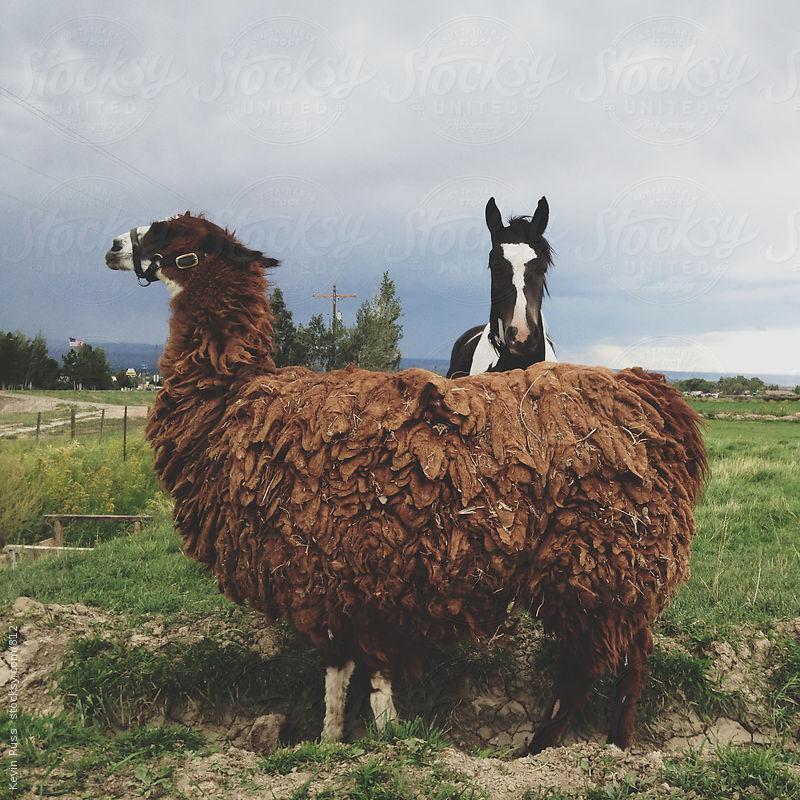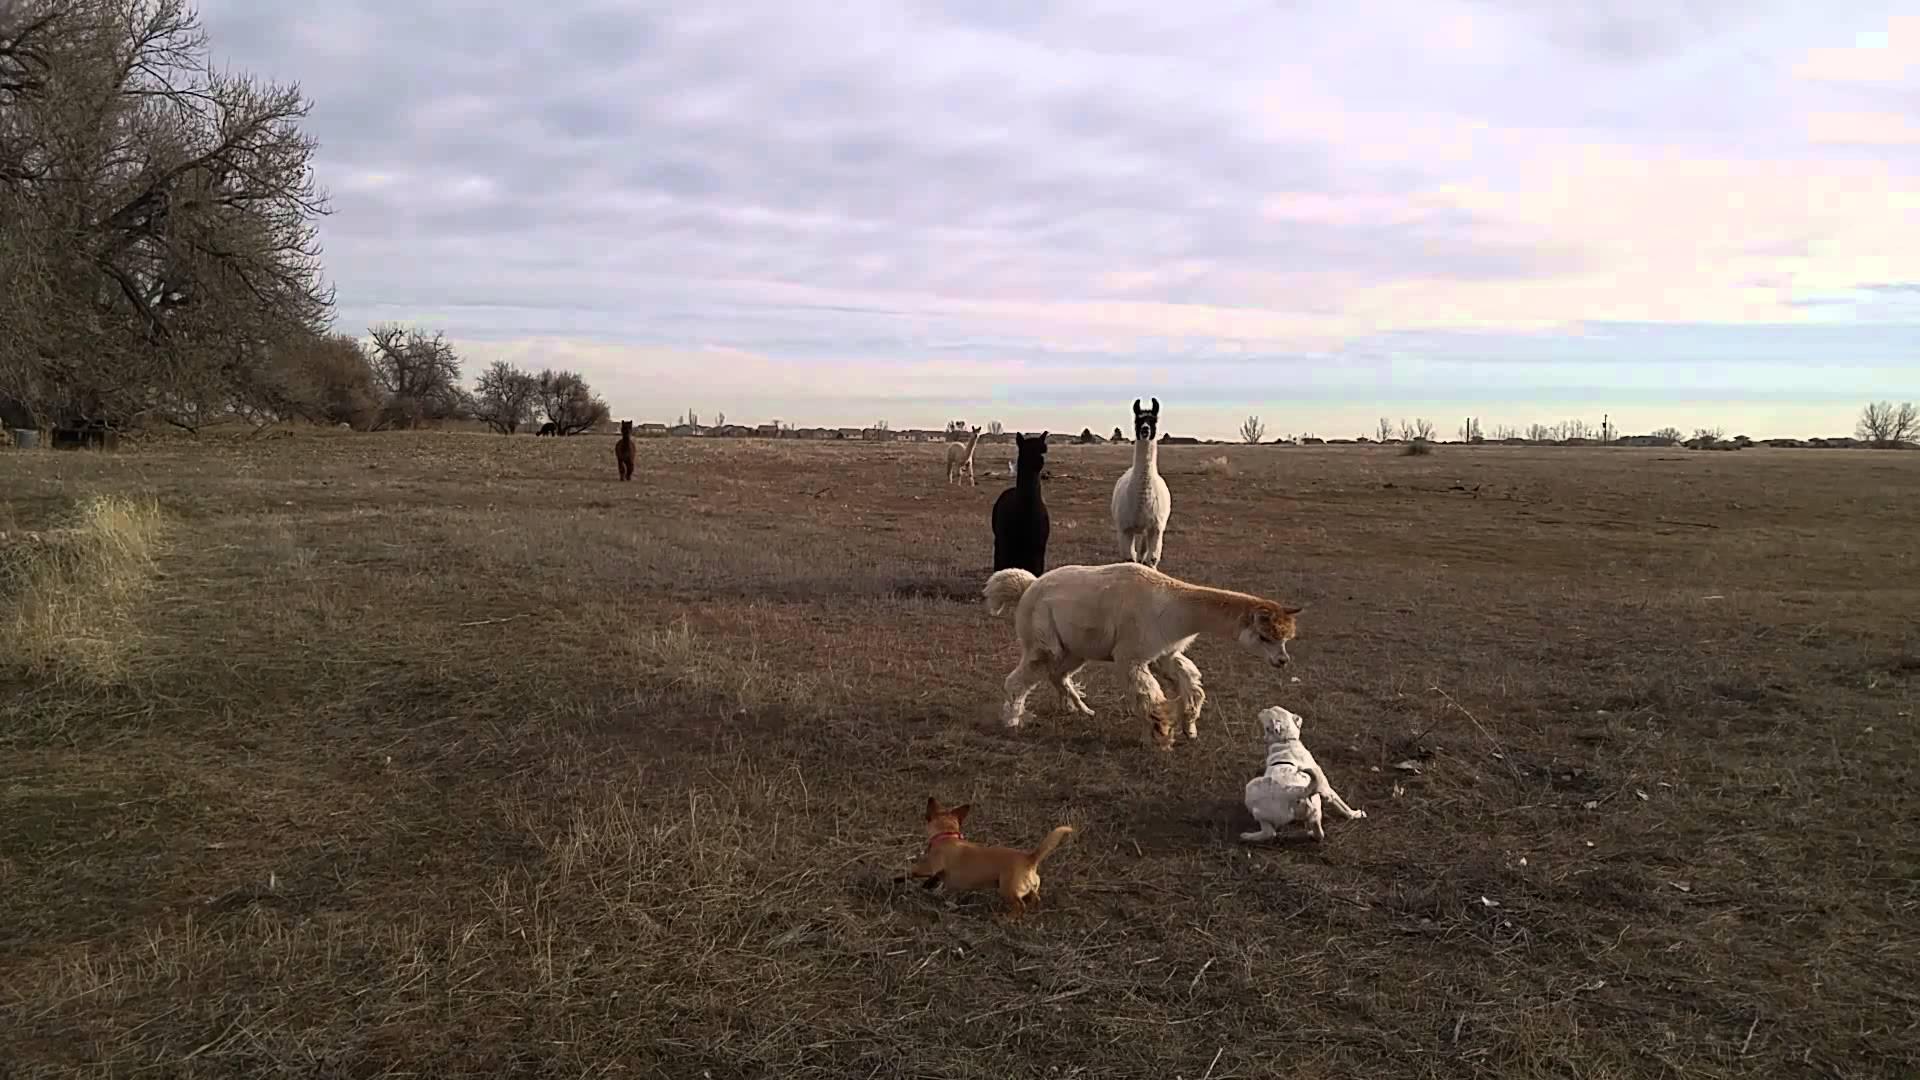The first image is the image on the left, the second image is the image on the right. Assess this claim about the two images: "In at least one image there are at least three mountain peaks behind a single llama.". Correct or not? Answer yes or no. No. The first image is the image on the left, the second image is the image on the right. Assess this claim about the two images: "The left image includes a leftward-facing brown-and-white llama standing at the edge of a cliff, with mountains in the background.". Correct or not? Answer yes or no. No. 